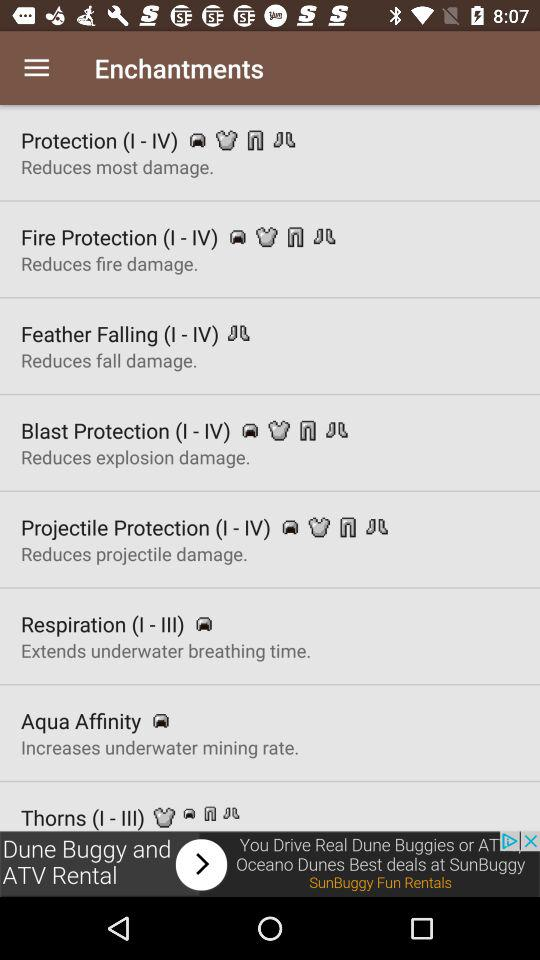What problem is solved by feather falling? The problem solved by Feather Falling is that it reduces fall damage. 